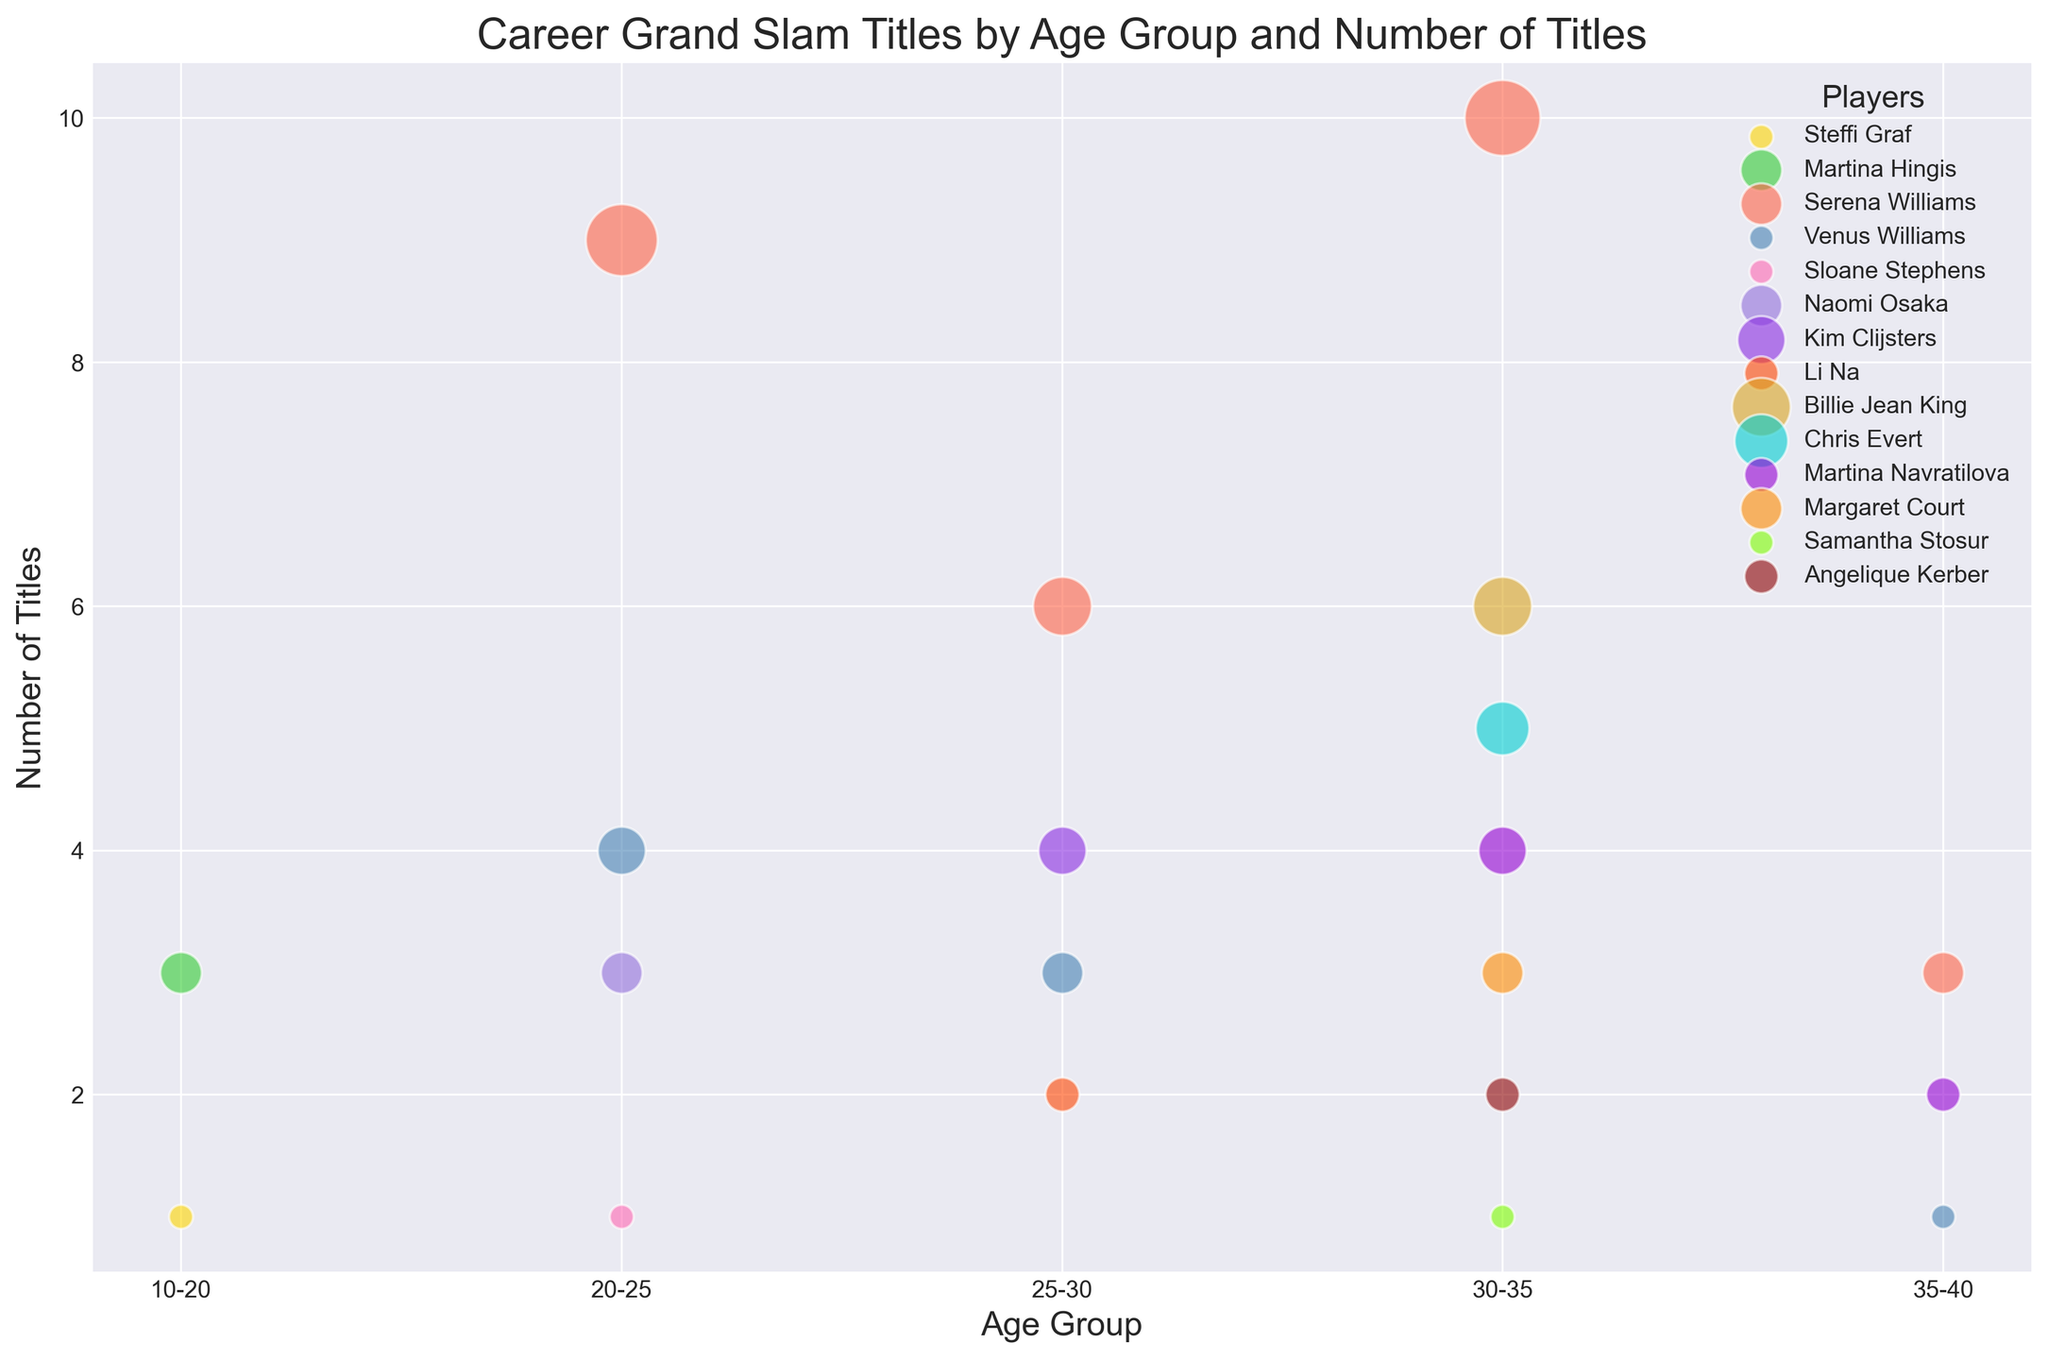Who has more Grand Slam titles in the age group 25-30, Serena Williams or Venus Williams? In the age group 25-30, Serena Williams has 6 titles, and Venus Williams has 3 titles. Comparing these values, Serena Williams has more.
Answer: Serena Williams How many total Grand Slam titles does Serena Williams have across all age groups, and in which age group does she have the most? Serena has the following titles: 9 (20-25), 6 (25-30), 10 (30-35), and 3 (35-40). Summing them up: 9 + 6 + 10 + 3 = 28 titles. The age group with the most titles is 30-35 (10 titles).
Answer: 28, 30-35 Which player in the age group 30-35 has the second highest number of Grand Slam titles? In the age group 30-35, the list of titles is: Serena Williams (10), Billie Jean King (6), Chris Evert (5), and others with fewer titles. The second highest is Billie Jean King with 6 titles.
Answer: Billie Jean King What is the sum of Grand Slam titles won by players in the age group 20-25? Summing the titles in the age group 20-25: Serena Williams (9), Venus Williams (4), Sloane Stephens (1), Naomi Osaka (3). So, 9 + 4 + 1 + 3 = 17 titles in total.
Answer: 17 Venus Williams vs. Serena Williams: Who won Grand Slam titles in more age groups, and how many groups did each win in? Venus Williams has titles in age groups 20-25 (4), 25-30 (3), and 35-40 (1), making it 3 age groups. Serena Williams has titles in age groups 20-25 (9), 25-30 (6), 30-35 (10), and 35-40 (3), making it 4 age groups. Serena won in more age groups.
Answer: Serena Williams, 3 vs. 4 How do the Grand Slam titles of Chris Evert in the age group 30-35 compare to those of Angelique Kerber in the same age group? In the age group 30-35, Chris Evert has 5 titles while Angelique Kerber has 2 titles. Chris Evert has more titles.
Answer: Chris Evert Identify the player with the least number of Grand Slam titles in the age group 25-30 and state the number. Within the age group 25-30, Li Na has 2 titles, which is the least number compared to others in this group.
Answer: Li Na, 2 What is the range of the number of Grand Slam titles in the age group 30-35? The minimum number of titles in 30-35 is 1 (Samantha Stosur), and the maximum is 10 (Serena Williams). The range is 10 - 1 = 9.
Answer: 9 